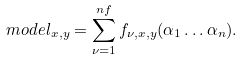<formula> <loc_0><loc_0><loc_500><loc_500>m o d e l _ { x , y } = \sum _ { \nu = 1 } ^ { n f } f _ { \nu , x , y } ( \alpha _ { 1 } \dots \alpha _ { n } ) .</formula> 